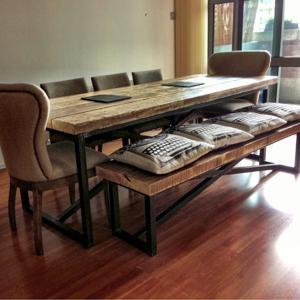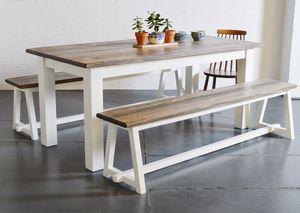The first image is the image on the left, the second image is the image on the right. Examine the images to the left and right. Is the description "There are four chairs in the image on the right." accurate? Answer yes or no. No. 